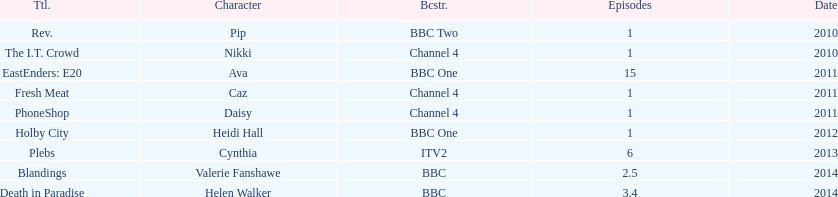How many titles only had one episode? 5. 